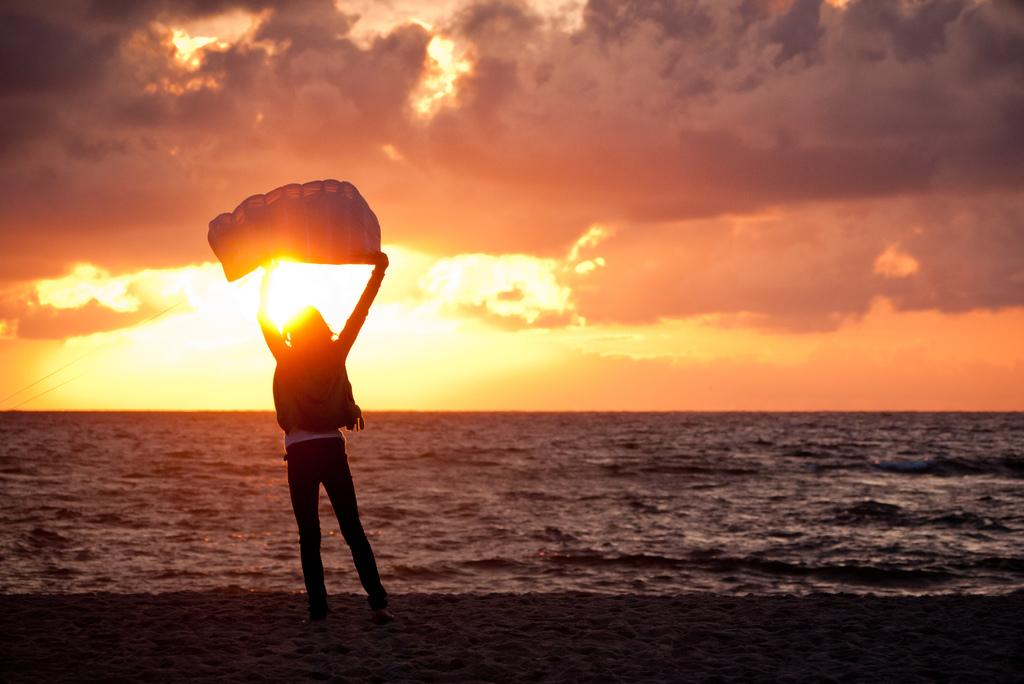What is the person in the image doing? The person is standing on the ground in the image. What is the person holding in the image? The person is holding an object in the image. What can be seen in the background of the image? There is a large water body visible in the background of the image. What is the condition of the sky in the image? The sky appears cloudy in the image. What grade is the beast receiving in the image? There is no beast present in the image, and therefore no grade can be assigned. How much honey is visible in the image? There is no honey present in the image. 